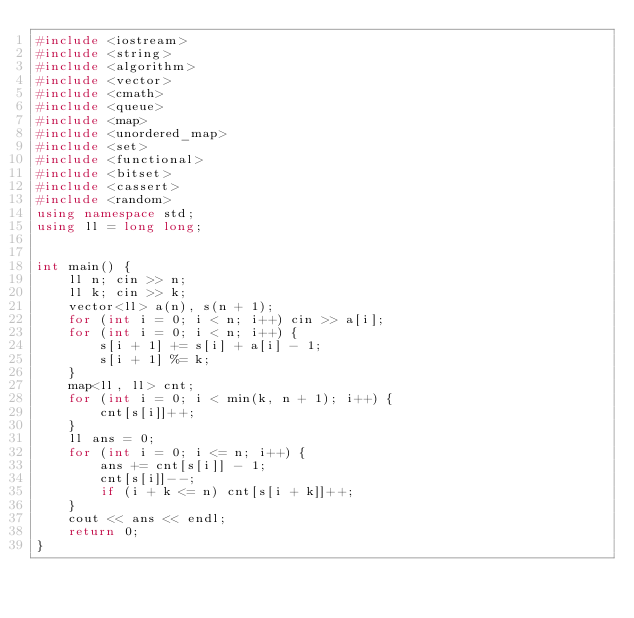<code> <loc_0><loc_0><loc_500><loc_500><_C++_>#include <iostream>
#include <string>
#include <algorithm>
#include <vector>
#include <cmath>
#include <queue>
#include <map>
#include <unordered_map>
#include <set>
#include <functional>
#include <bitset>
#include <cassert>
#include <random>
using namespace std;
using ll = long long;


int main() {
	ll n; cin >> n;
	ll k; cin >> k;
	vector<ll> a(n), s(n + 1);
	for (int i = 0; i < n; i++) cin >> a[i];
	for (int i = 0; i < n; i++) {
		s[i + 1] += s[i] + a[i] - 1;
		s[i + 1] %= k;
	}
	map<ll, ll> cnt;
	for (int i = 0; i < min(k, n + 1); i++) {
		cnt[s[i]]++;
	}
	ll ans = 0;
	for (int i = 0; i <= n; i++) {
		ans += cnt[s[i]] - 1;
		cnt[s[i]]--;
		if (i + k <= n) cnt[s[i + k]]++;
	}
	cout << ans << endl;
	return 0;
}</code> 